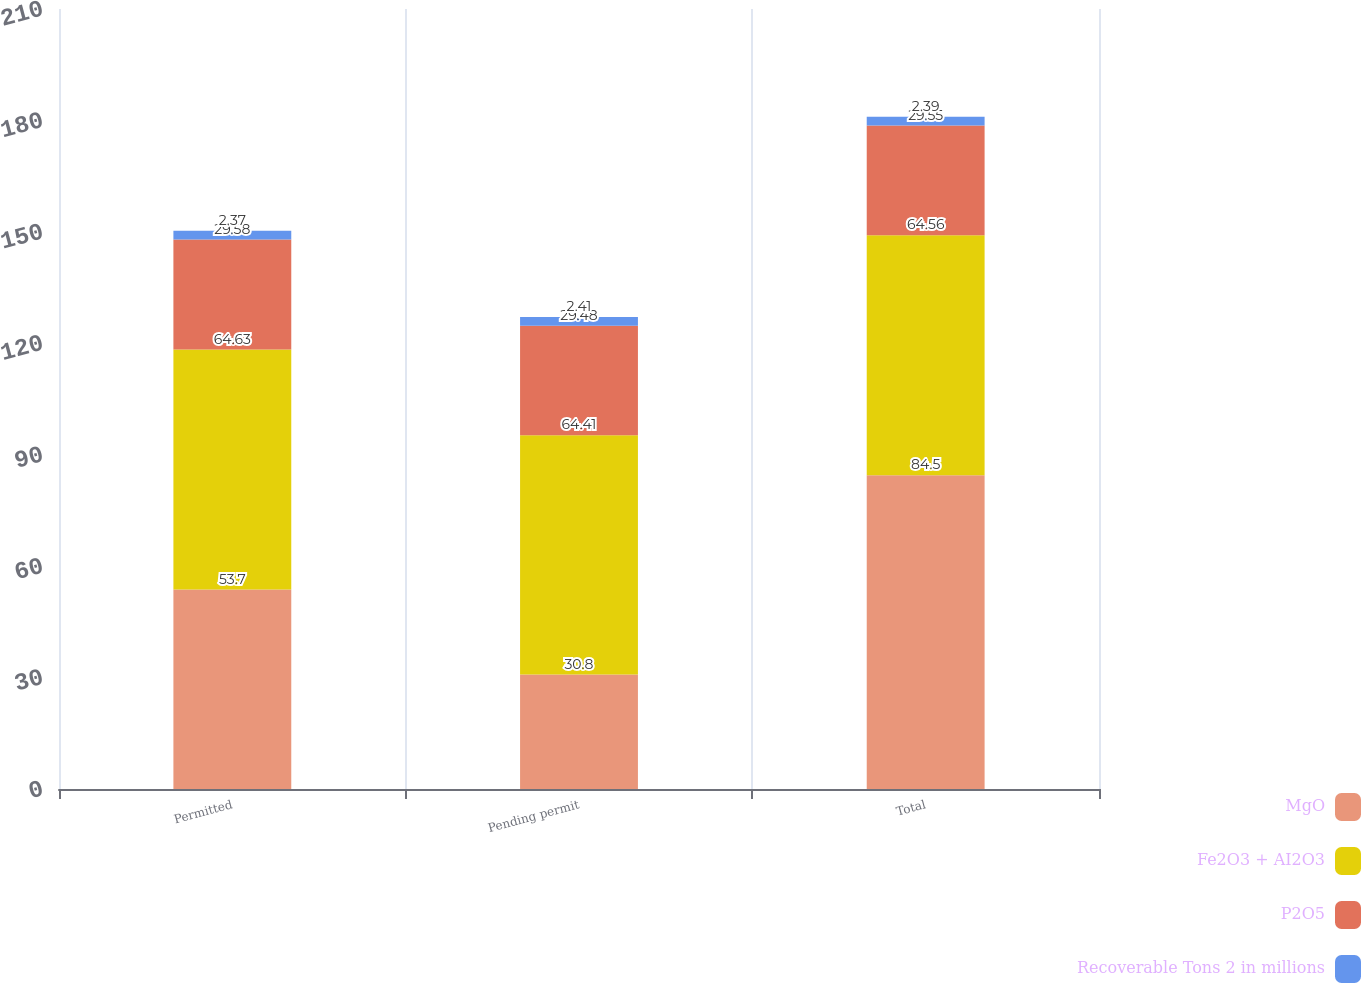Convert chart. <chart><loc_0><loc_0><loc_500><loc_500><stacked_bar_chart><ecel><fcel>Permitted<fcel>Pending permit<fcel>Total<nl><fcel>MgO<fcel>53.7<fcel>30.8<fcel>84.5<nl><fcel>Fe2O3 + AI2O3<fcel>64.63<fcel>64.41<fcel>64.56<nl><fcel>P2O5<fcel>29.58<fcel>29.48<fcel>29.55<nl><fcel>Recoverable Tons 2 in millions<fcel>2.37<fcel>2.41<fcel>2.39<nl></chart> 